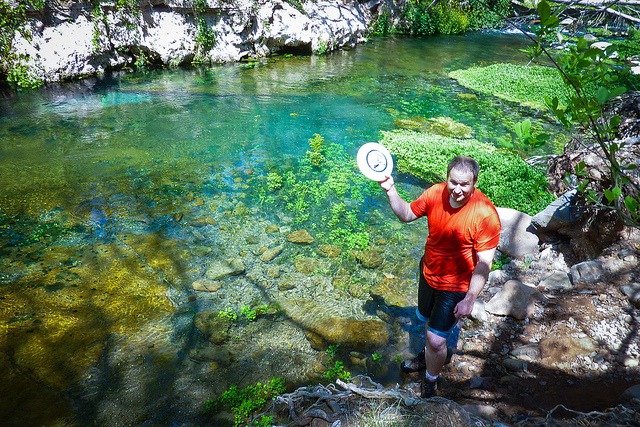How many elephants are behind the fence? 0 